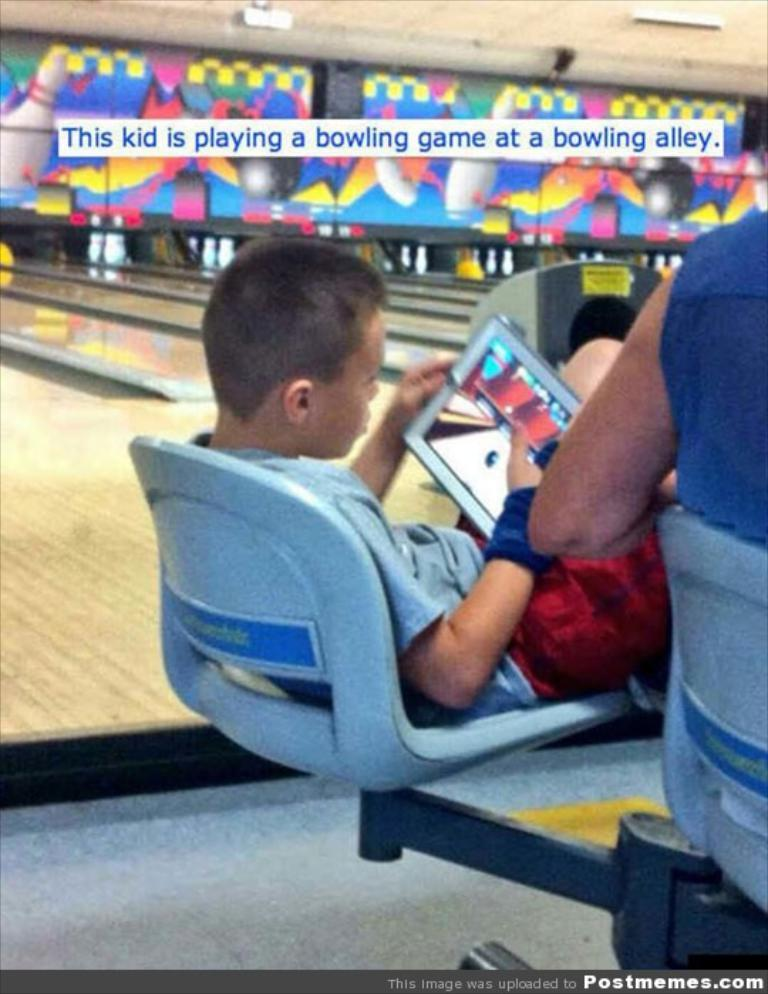<image>
Share a concise interpretation of the image provided. A text box that reads this kid is playing a bowling game at a bowling alley is above the kid's head. 